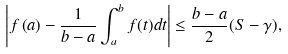<formula> <loc_0><loc_0><loc_500><loc_500>\left | f \left ( a \right ) - \frac { 1 } { b - a } \int _ { a } ^ { b } f ( t ) d t \right | \leq \frac { b - a } { 2 } ( S - \gamma ) ,</formula> 